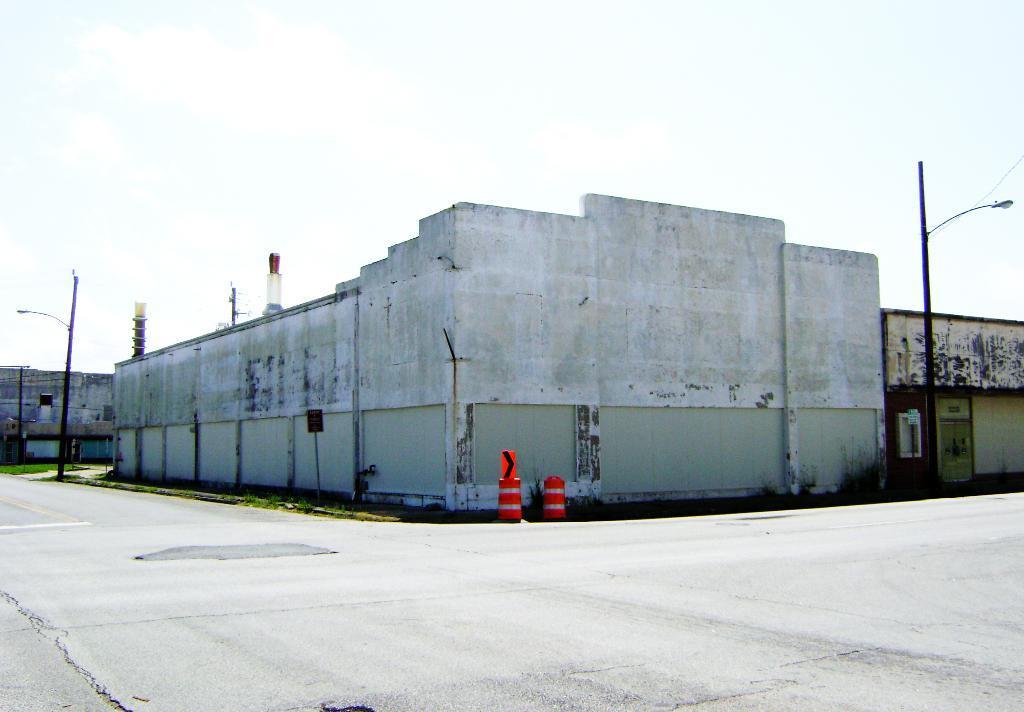Describe this image in one or two sentences. In this picture we can see the road, grass, poles, buildings, some objects and in the background we can see the sky. 